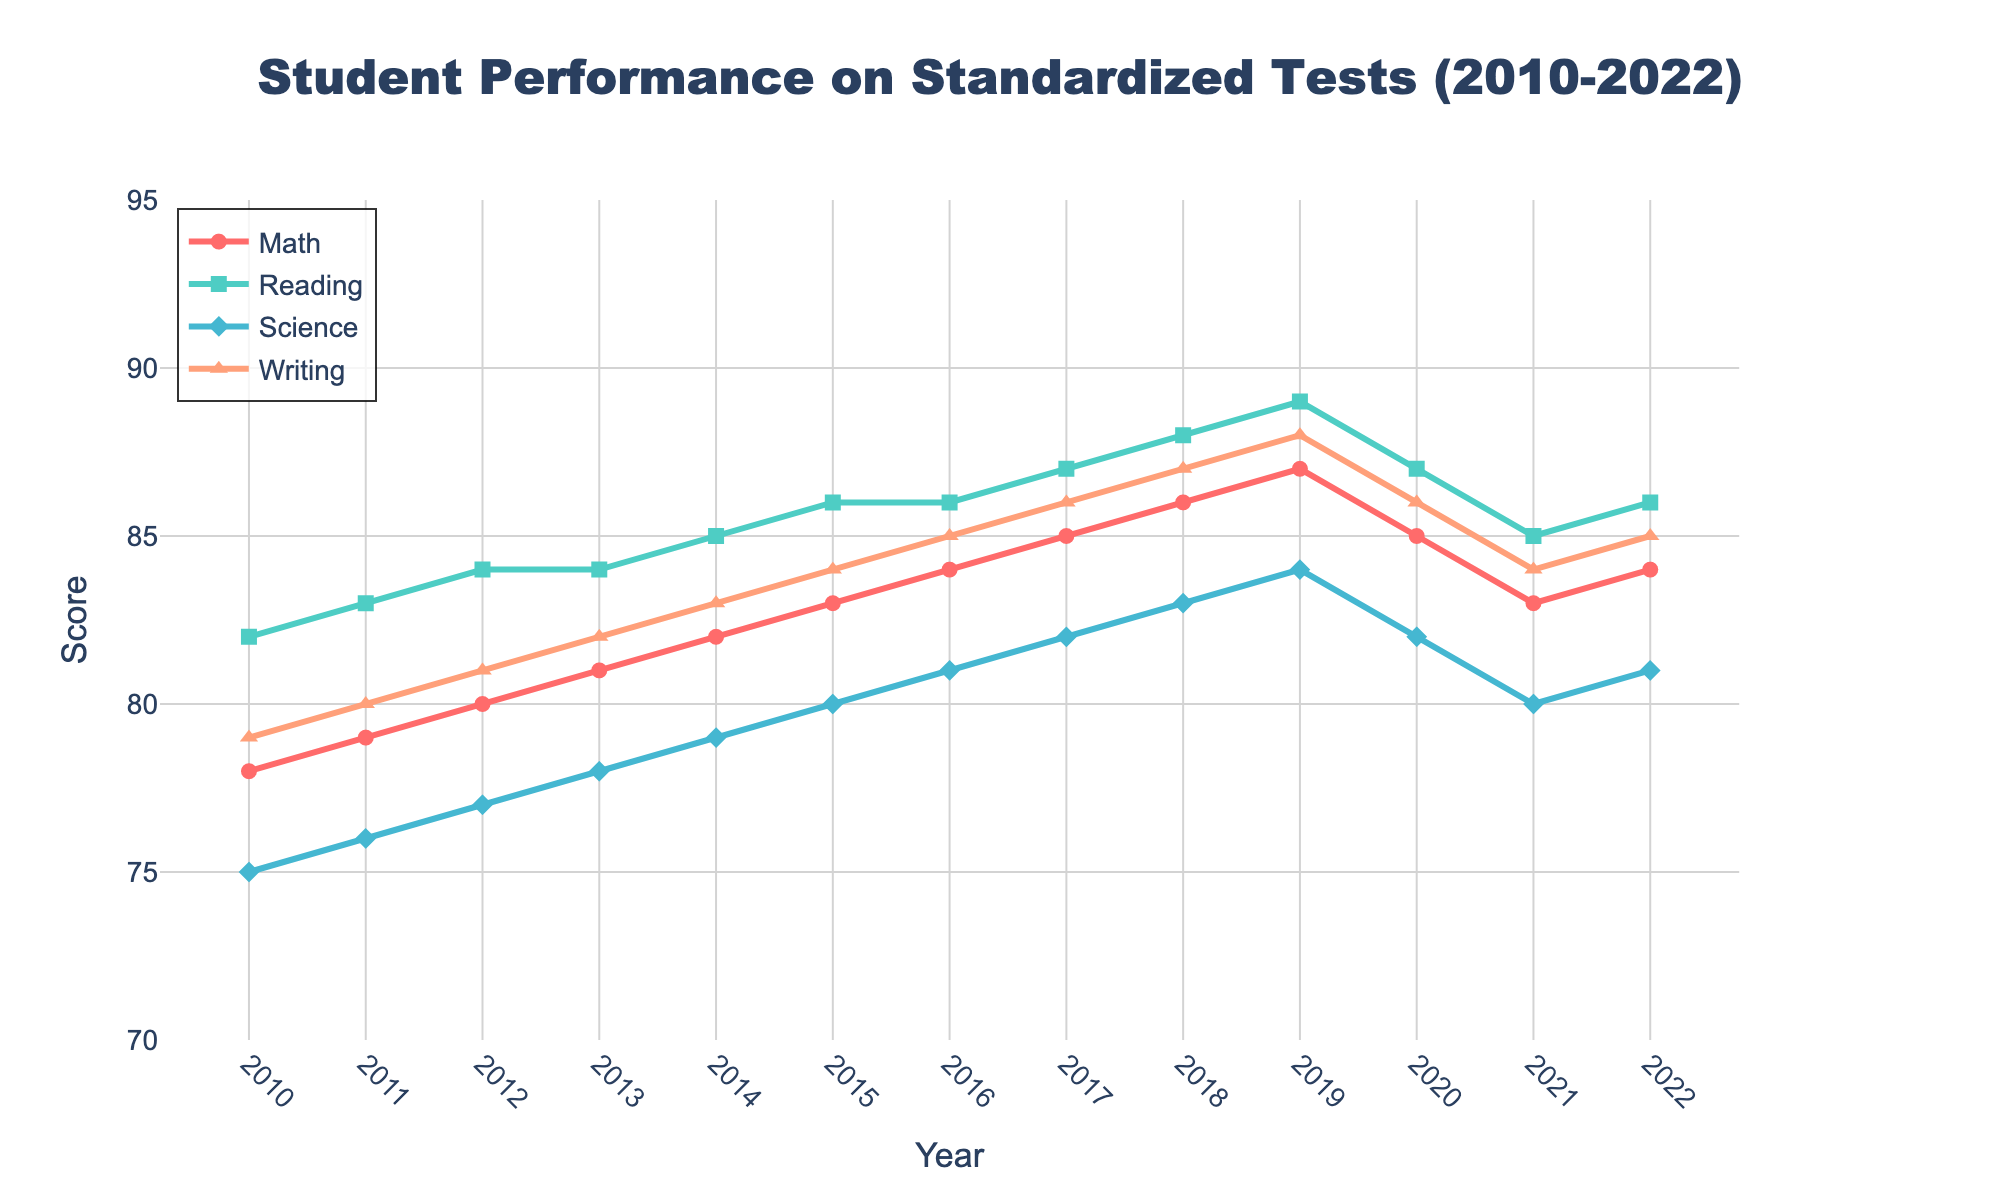What is the trend in Math scores from 2010 to 2022? The Math scores show a general upward trend from 78 in 2010 to 87 in 2019. There is a slight drop to 85 in 2020 and 83 in 2021, with a partial recovery to 84 in 2022.
Answer: Upward, with a slight drop in 2020-2021 How do Reading scores in 2010 compare to Writing scores in 2022? Reading scores in 2010 are 82. Writing scores in 2022 are 85. Comparing these values shows that Writing scores in 2022 are higher by 3 points.
Answer: Writing scores are 3 points higher Which subject has the highest score in 2019? According to the 2019 data, Reading scores are 89, which is higher than Math (87), Science (84), and Writing (88). Therefore, Reading has the highest score in 2019.
Answer: Reading What is the average score for Science between 2010 and 2022? The sum of Science scores across the years 2010 to 2022 is 75 + 76 + 77 + 78 + 79 + 80 + 81 + 82 + 83 + 84 + 82 + 80 + 81 = 999. Dividing by the number of years (13), the average is 999 / 13 ≈ 76.85.
Answer: Approximately 76.85 Which year shows equal scores for Reading and Writing? In 2016, the scores for both Reading and Writing are 86, making this the year where the scores are equal.
Answer: 2016 Between which two consecutive years is the largest increase in Science scores observed? Examining the yearly differences, the largest increase in Science scores occurs from 2011 to 2012, with an increase from 76 to 77 (an increase of 1 point).
Answer: 2011 to 2012 By how much did Math scores improve from 2013 to 2019? Math scores improved from 81 in 2013 to 87 in 2019. The improvement is 87 - 81 = 6.
Answer: 6 points Visualize the colors associated with each subject. What color represents Science? The colors used are red for Math, green for Reading, blue for Science, and orange for Writing. Therefore, Science is represented by blue.
Answer: Blue What are the overall trends observed in Writing scores from 2010 to 2022? Writing scores gradually increase from 79 in 2010 to 88 in 2019, then they drop to 86 in 2020 and further to 84 in 2021, before slightly rising to 85 in 2022.
Answer: Upward overall, with a drop in 2020-2021 If a student scores 80 in Reading in 2021, is it above or below the average Reading score from 2010 to 2022? The sum of Reading scores from 2010 to 2022 is 82 + 83 + 84 + 84 + 85 + 86 + 86 + 87 + 88 + 89 + 87 + 85 + 86 = 1122. Dividing by 13 years, the average is 1122 / 13 ≈ 86.46. Therefore, a score of 80 in 2021 is below the average.
Answer: Below How did Math scores change from 2018 to 2020? Math scores increased from 86 in 2018 to 87 in 2019 but then dropped to 85 in 2020.
Answer: Increased, then decreased 